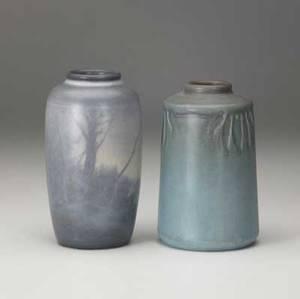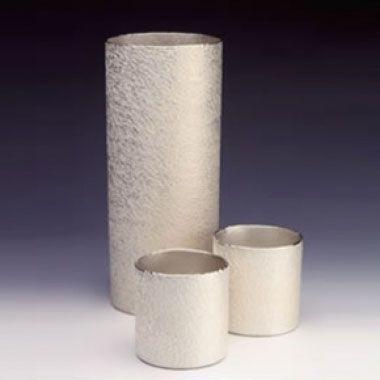The first image is the image on the left, the second image is the image on the right. For the images displayed, is the sentence "One image shows two vases that are similar in size with top openings that are smaller than the body of the vase, but that are different designs." factually correct? Answer yes or no. Yes. The first image is the image on the left, the second image is the image on the right. For the images displayed, is the sentence "One image shows a neutral-colored vase with a base that is not round." factually correct? Answer yes or no. No. 